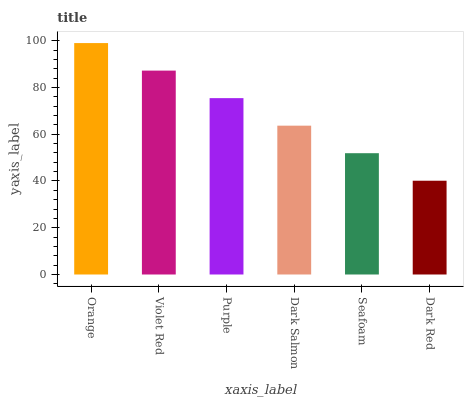Is Violet Red the minimum?
Answer yes or no. No. Is Violet Red the maximum?
Answer yes or no. No. Is Orange greater than Violet Red?
Answer yes or no. Yes. Is Violet Red less than Orange?
Answer yes or no. Yes. Is Violet Red greater than Orange?
Answer yes or no. No. Is Orange less than Violet Red?
Answer yes or no. No. Is Purple the high median?
Answer yes or no. Yes. Is Dark Salmon the low median?
Answer yes or no. Yes. Is Dark Salmon the high median?
Answer yes or no. No. Is Orange the low median?
Answer yes or no. No. 